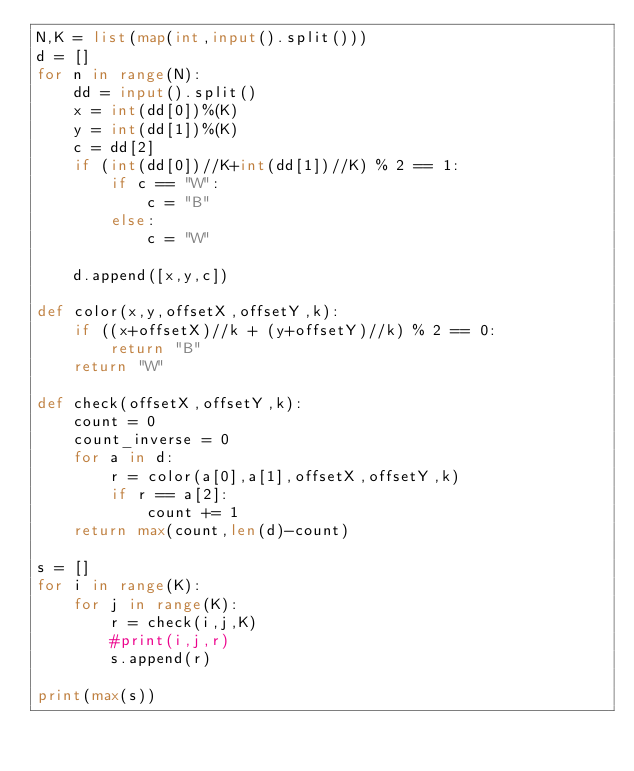<code> <loc_0><loc_0><loc_500><loc_500><_Python_>N,K = list(map(int,input().split()))
d = []
for n in range(N):
    dd = input().split()
    x = int(dd[0])%(K)
    y = int(dd[1])%(K)
    c = dd[2]
    if (int(dd[0])//K+int(dd[1])//K) % 2 == 1:
        if c == "W":
            c = "B"
        else:
            c = "W"

    d.append([x,y,c])

def color(x,y,offsetX,offsetY,k):
    if ((x+offsetX)//k + (y+offsetY)//k) % 2 == 0:
        return "B"
    return "W"

def check(offsetX,offsetY,k):
    count = 0
    count_inverse = 0
    for a in d:
        r = color(a[0],a[1],offsetX,offsetY,k)
        if r == a[2]:
            count += 1
    return max(count,len(d)-count)

s = []
for i in range(K):
    for j in range(K):
        r = check(i,j,K)
        #print(i,j,r)
        s.append(r)

print(max(s))
</code> 